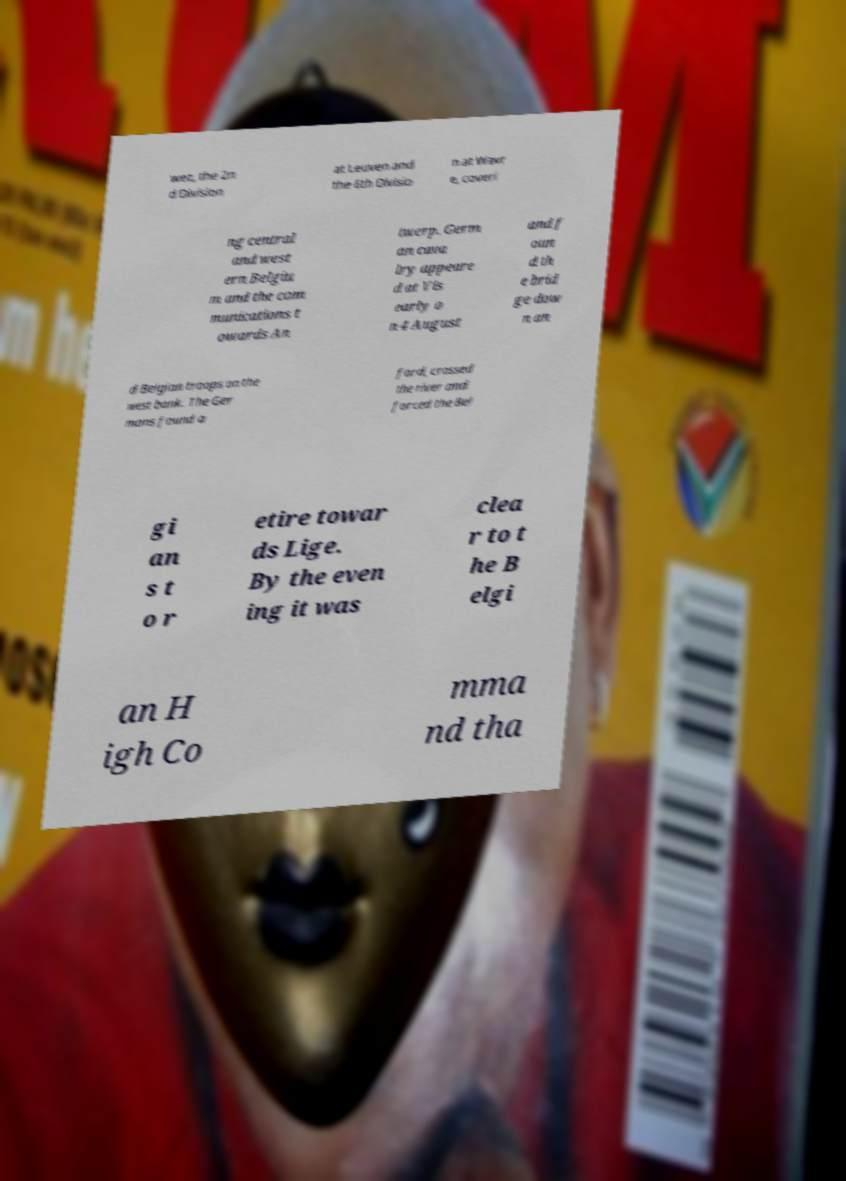There's text embedded in this image that I need extracted. Can you transcribe it verbatim? wez, the 2n d Division at Leuven and the 6th Divisio n at Wavr e, coveri ng central and west ern Belgiu m and the com munications t owards An twerp. Germ an cava lry appeare d at Vis early o n 4 August and f oun d th e brid ge dow n an d Belgian troops on the west bank. The Ger mans found a ford, crossed the river and forced the Bel gi an s t o r etire towar ds Lige. By the even ing it was clea r to t he B elgi an H igh Co mma nd tha 